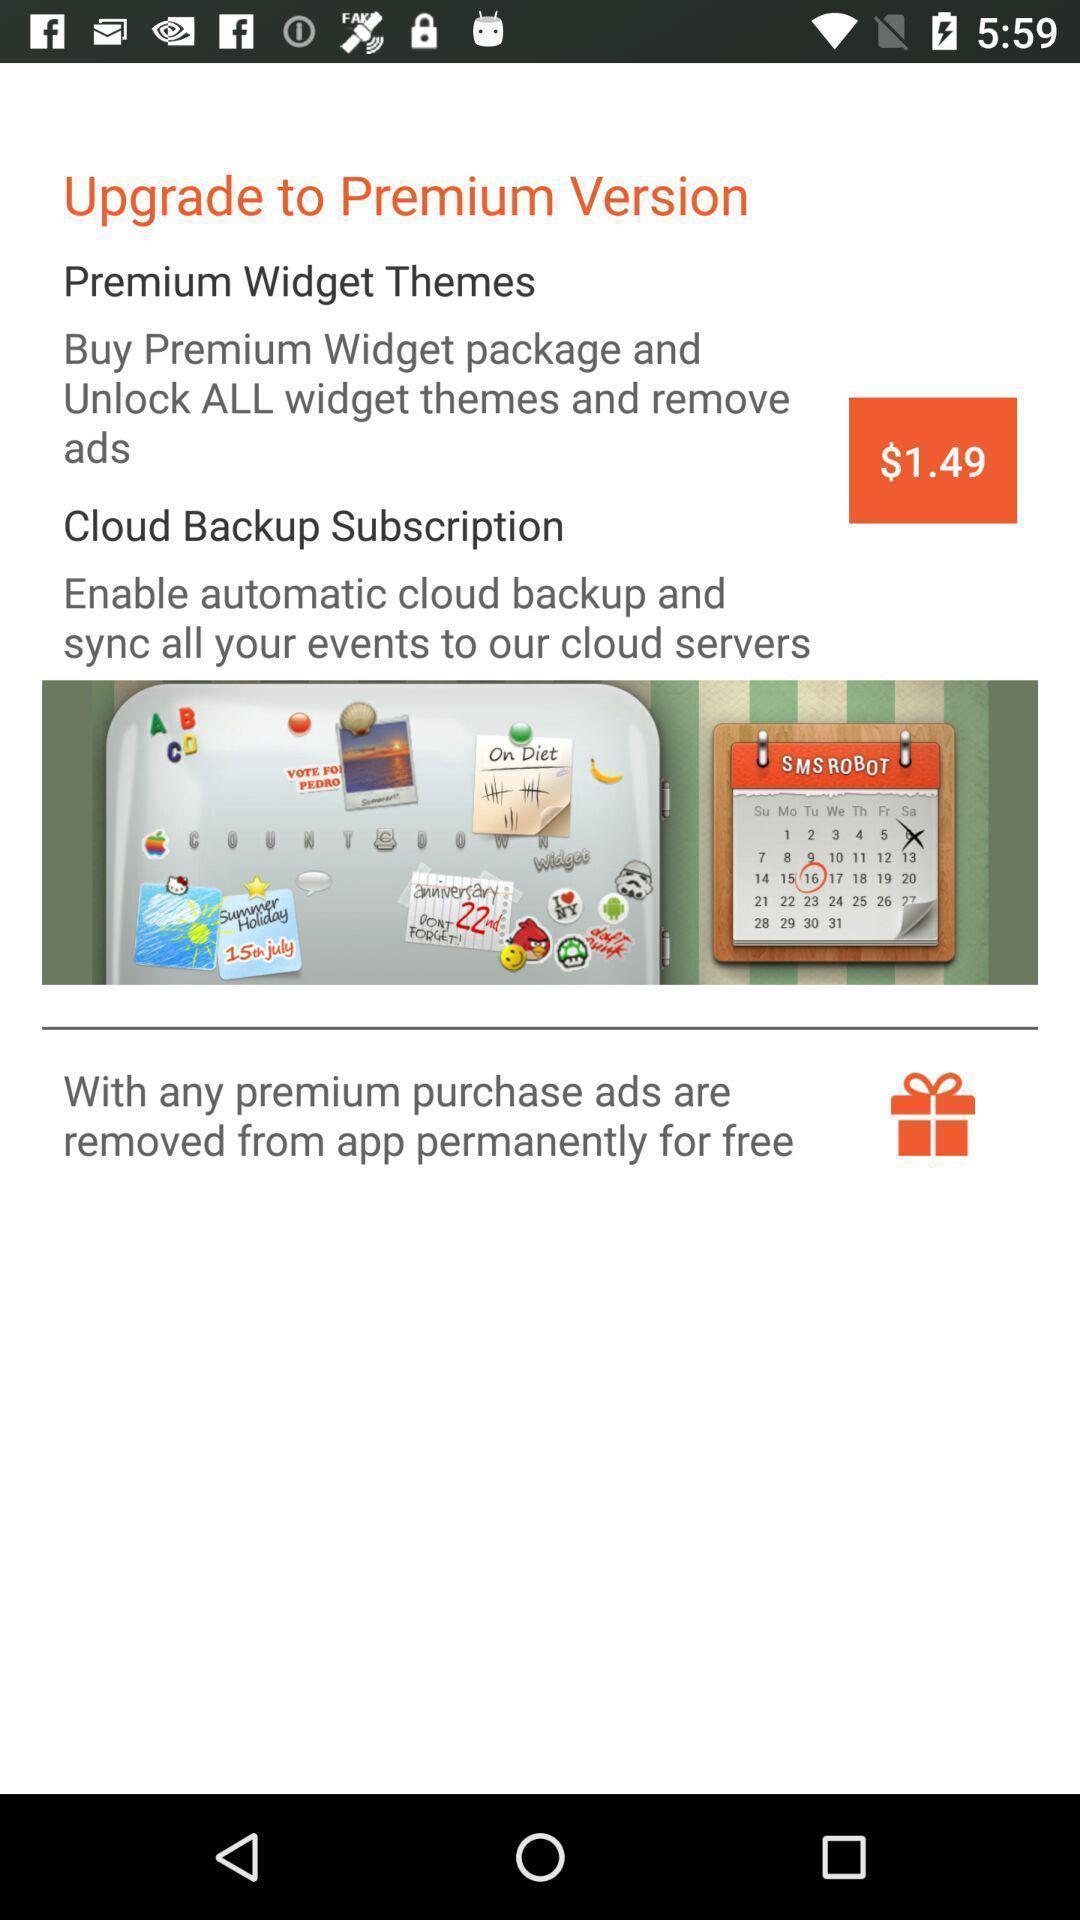Describe this image in words. Screen displaying notification tp upgrade version. 